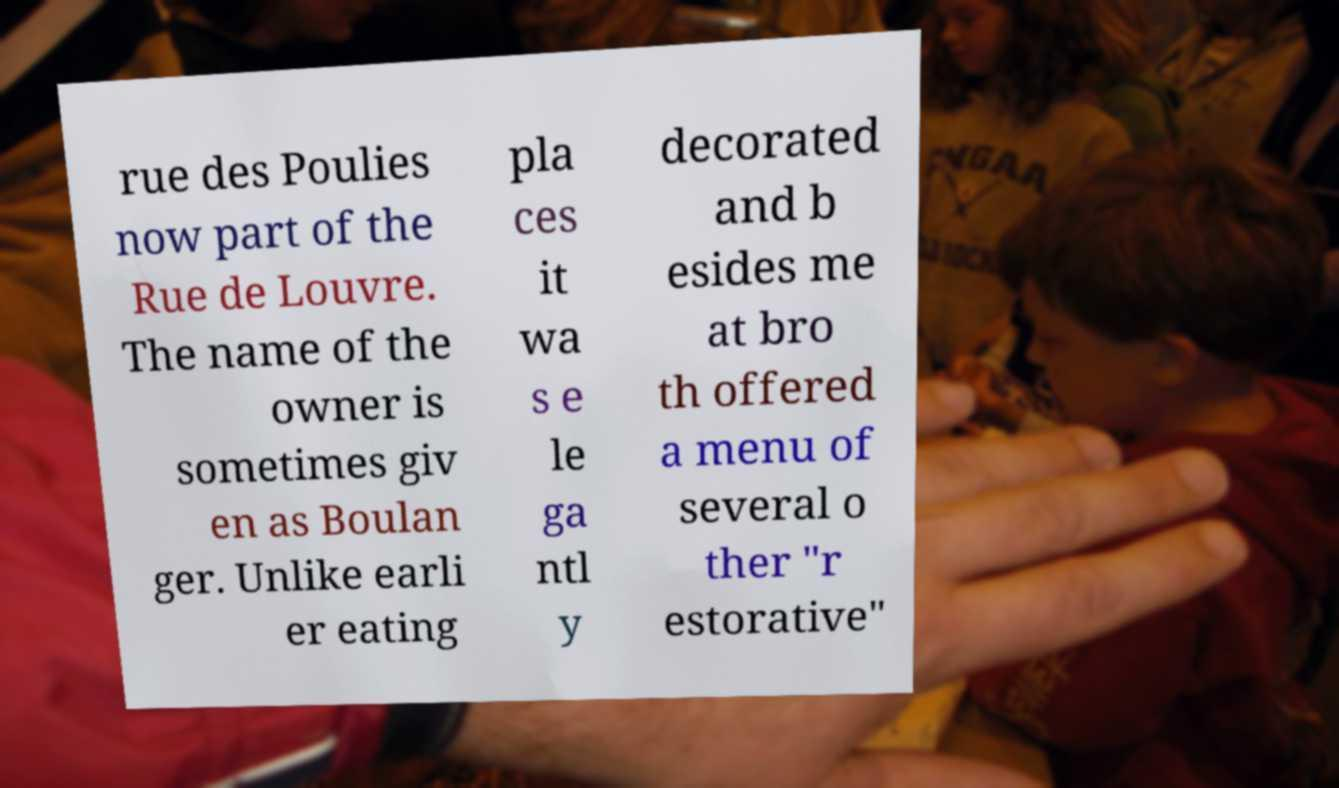I need the written content from this picture converted into text. Can you do that? rue des Poulies now part of the Rue de Louvre. The name of the owner is sometimes giv en as Boulan ger. Unlike earli er eating pla ces it wa s e le ga ntl y decorated and b esides me at bro th offered a menu of several o ther "r estorative" 